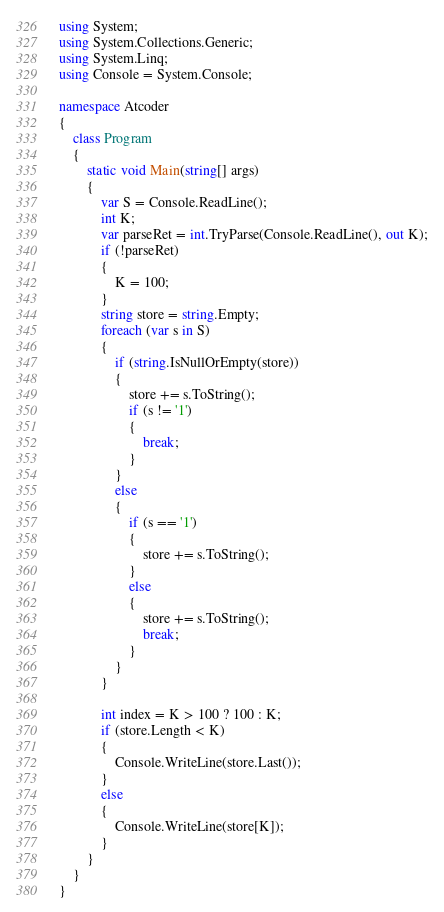Convert code to text. <code><loc_0><loc_0><loc_500><loc_500><_C#_>using System;
using System.Collections.Generic;
using System.Linq;
using Console = System.Console;

namespace Atcoder
{
    class Program
    {
        static void Main(string[] args)
        {
            var S = Console.ReadLine();
            int K;
            var parseRet = int.TryParse(Console.ReadLine(), out K);
            if (!parseRet)
            {
                K = 100;
            }
            string store = string.Empty;
            foreach (var s in S)
            {
                if (string.IsNullOrEmpty(store))
                {
                    store += s.ToString();
                    if (s != '1')
                    {
                        break;
                    }
                }
                else
                {
                    if (s == '1')
                    {
                        store += s.ToString();
                    }
                    else
                    {
                        store += s.ToString();
                        break;
                    }
                }
            }

            int index = K > 100 ? 100 : K;
            if (store.Length < K)
            {
                Console.WriteLine(store.Last());
            }
            else
            {
                Console.WriteLine(store[K]);
            }
        }
    }
}</code> 